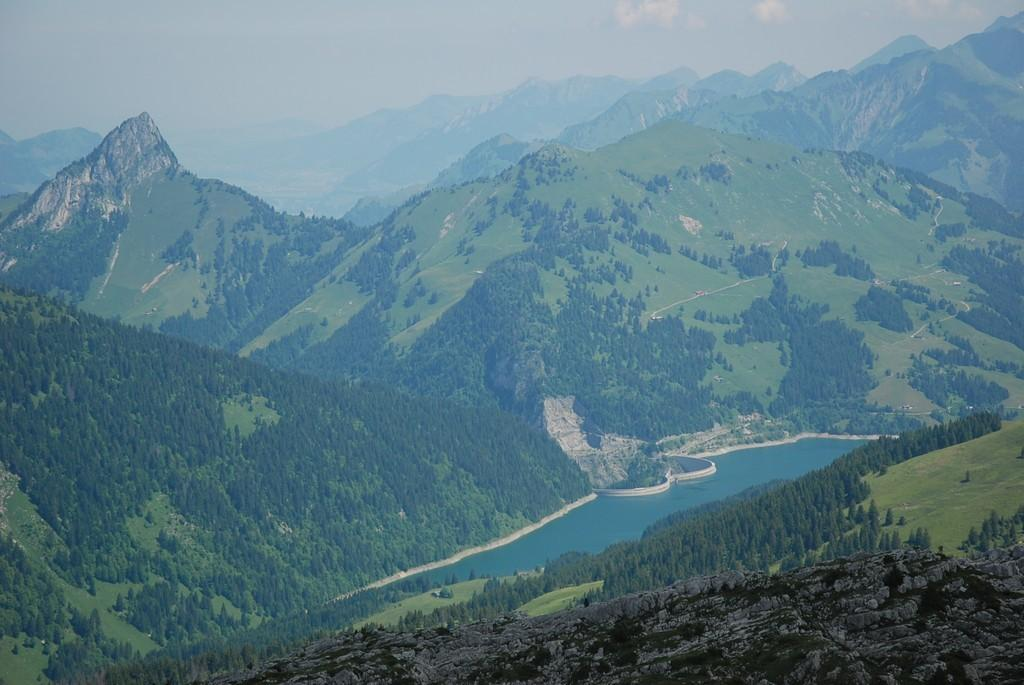What type of natural feature is depicted in the image? There is a river in the image. What can be seen in the mountains in the image? Trees are present in the mountains in the image. What is visible at the top of the image? The sky is visible at the top of the image. What type of wall can be seen in the image? There is no wall present in the image; it features a river, mountains, trees, and the sky. Can you identify any faces in the image? There are no faces visible in the image. 